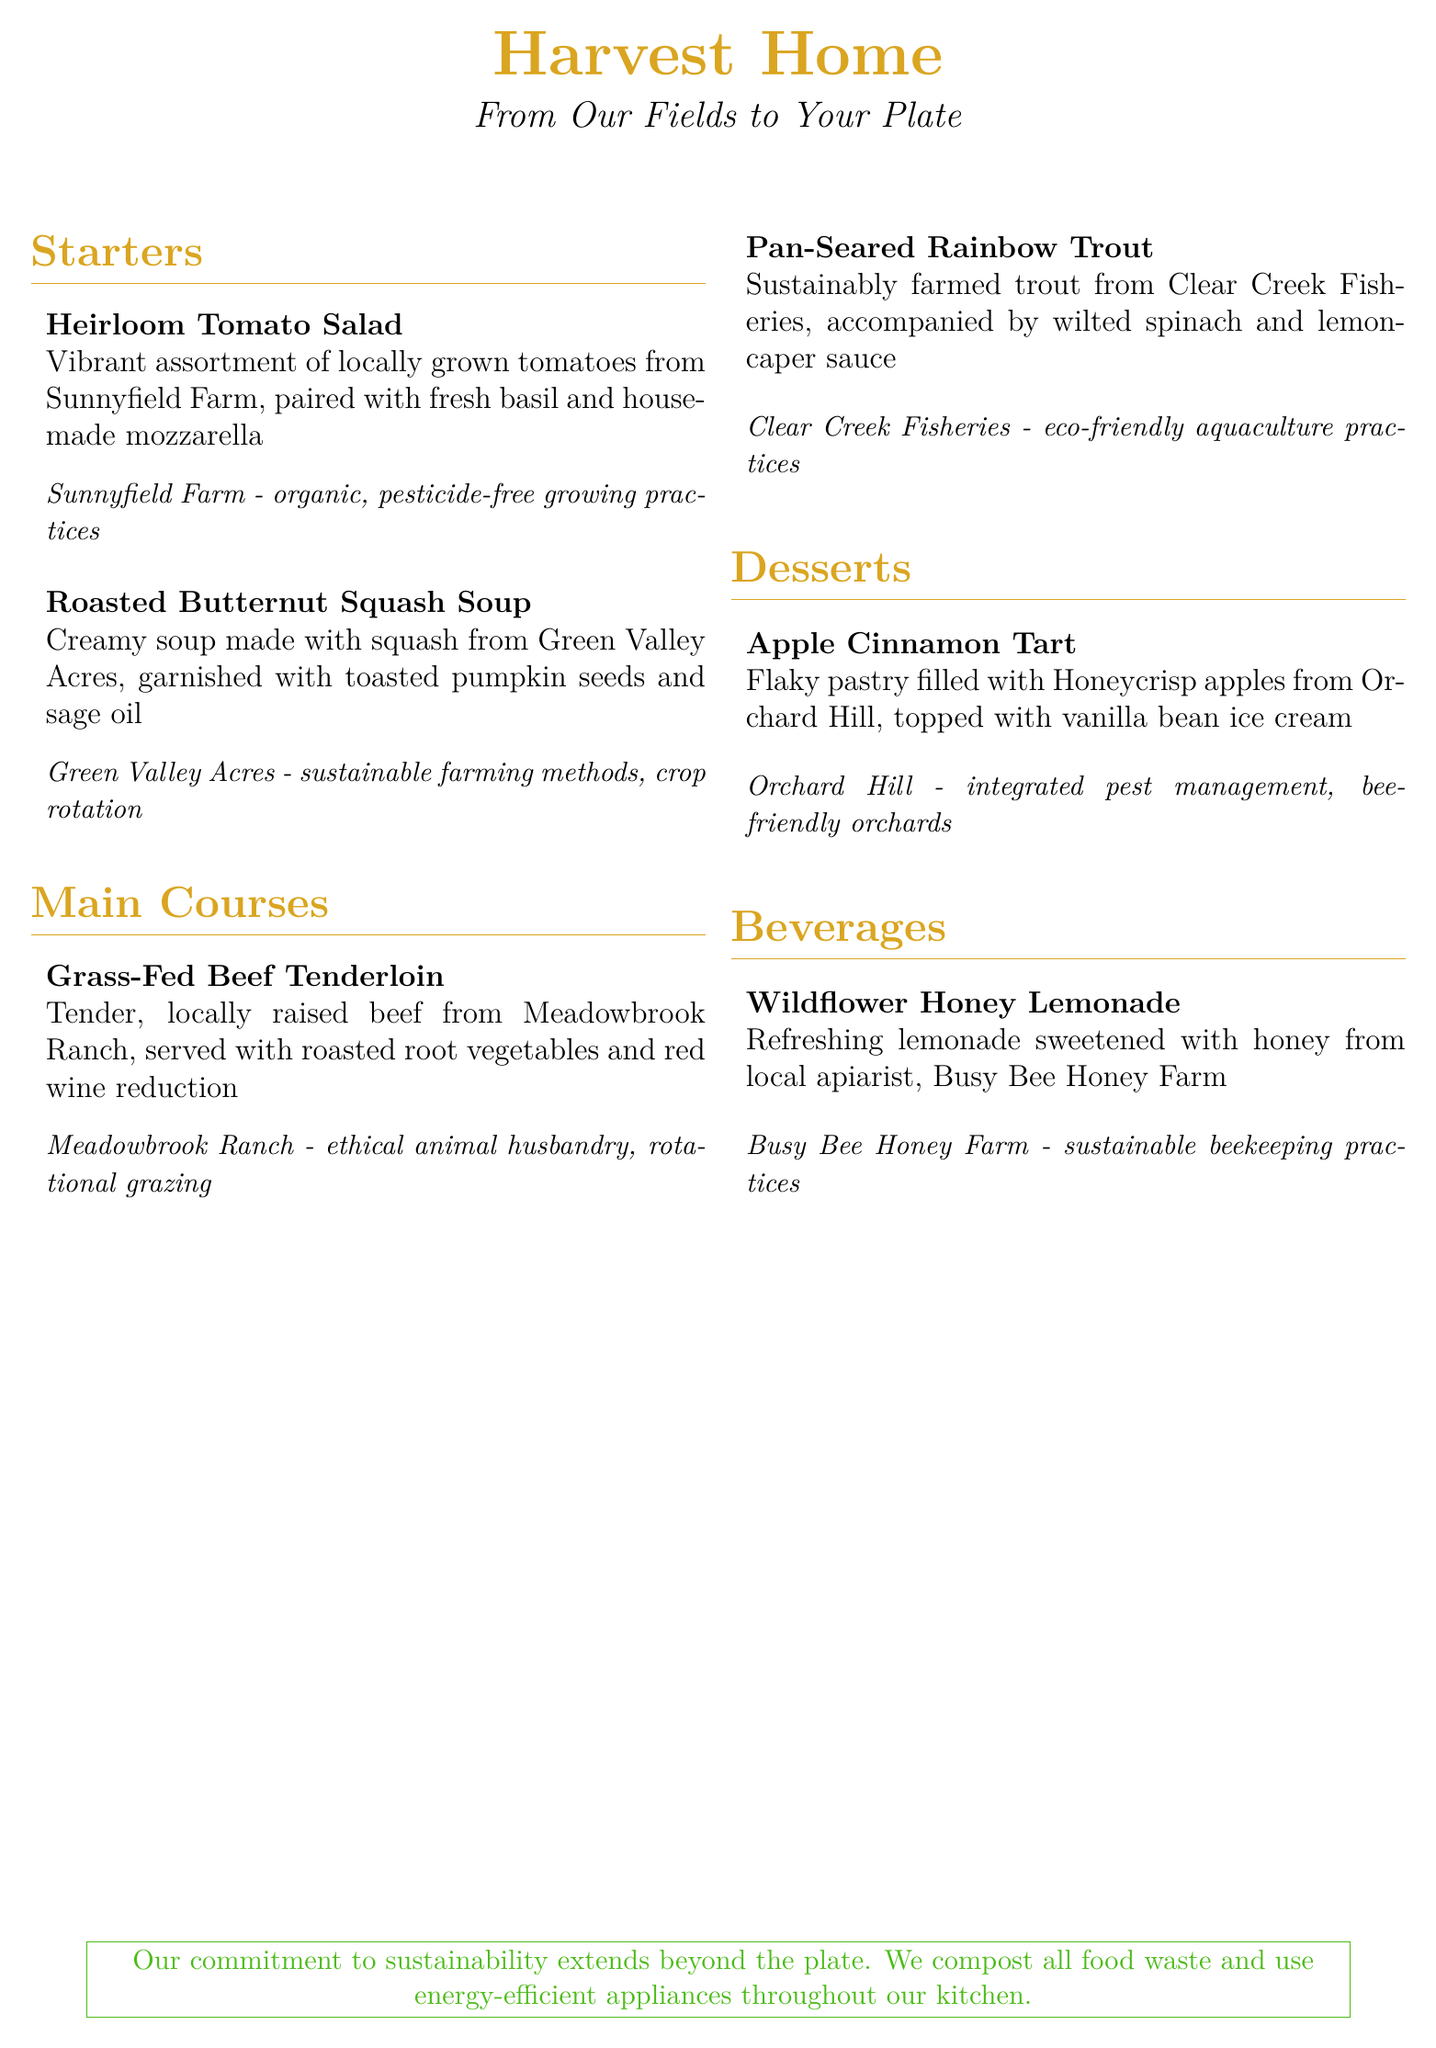What is the name of the restaurant? The name of the restaurant is prominently displayed at the top of the document.
Answer: Harvest Home What ingredients are used in the Heirloom Tomato Salad? The ingredients of the salad are specified in the menu description.
Answer: Heirloom tomatoes, basil, house-made mozzarella Which farm supplies the squash for the Roasted Butternut Squash Soup? The document mentions the source of the squash in the item description.
Answer: Green Valley Acres What type of fish is served in the Pan-Seared Rainbow Trout dish? The menu provides the type of fish used in the dish description.
Answer: Rainbow trout What farming practice does Meadowbrook Ranch use? The document describes the farming practices used by the ranch under the beef tenderloin item.
Answer: Rotational grazing How many main course options are listed on the menu? The menu lists the number of main courses under the respective section.
Answer: 2 What dessert is topped with vanilla bean ice cream? The dessert description indicates which one is paired with ice cream.
Answer: Apple Cinnamon Tart What farm provides honey for the Wildflower Honey Lemonade? The source of the honey is mentioned in the beverage description.
Answer: Busy Bee Honey Farm What is the commitment of the restaurant mentioned in the footer? The footer describes the restaurant's commitment to sustainability practices.
Answer: Compost all food waste and use energy-efficient appliances 